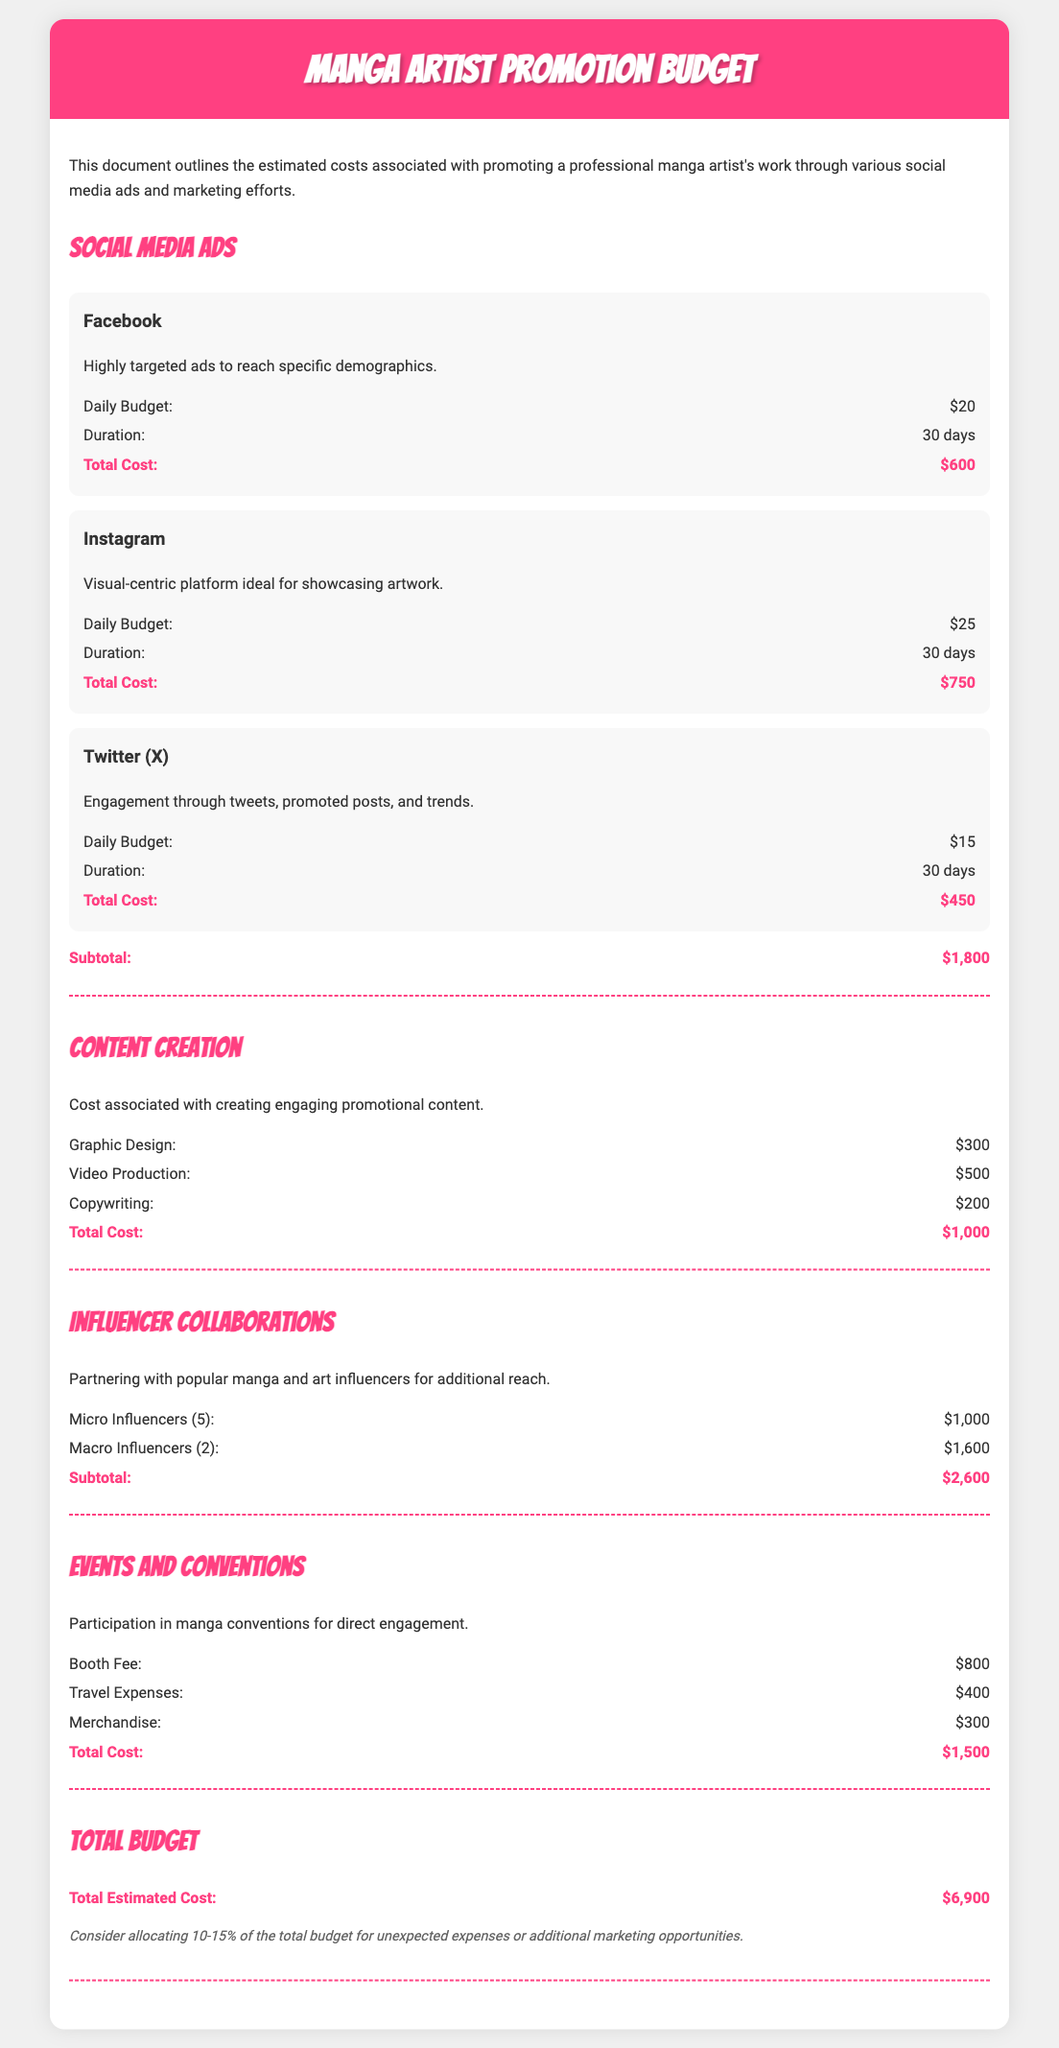What is the total estimated cost? The total estimated cost is listed in the document under the Total Budget section, which sums up all costs.
Answer: $6,900 What is the daily budget for Instagram ads? The daily budget for Instagram ads is specified in the Social Media Ads section.
Answer: $25 How many micro influencers are included in the budget? The document details the costs for influencer collaborations, indicating the number of micro influencers.
Answer: 5 What is the total cost for content creation? The total cost for content creation is provided in the Content Creation section of the document.
Answer: $1,000 What are the travel expenses for events and conventions? The travel expenses for events and conventions are outlined in the Events and Conventions section.
Answer: $400 What platform has the highest total cost for ads? The total costs for each platform are compared in the Social Media Ads section, identifying the platform with the highest amount.
Answer: Instagram What is the subtotal for influencer collaborations? The subtotal for influencer collaborations is noted at the end of that section in the document.
Answer: $2,600 What is the booth fee for events and conventions? The booth fee is detailed in the Events and Conventions section of the budget.
Answer: $800 